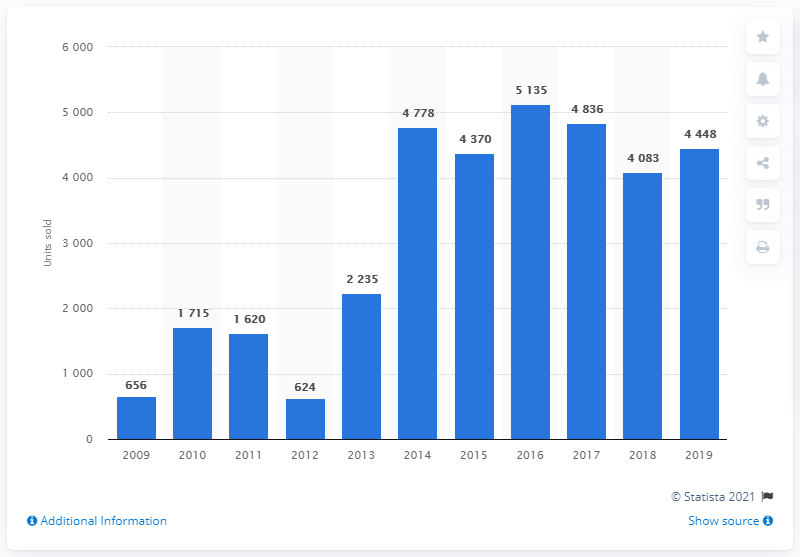List a handful of essential elements in this visual. During the period of 2009 to 2019, a total of 5,135 Dacia cars were sold in Sweden, which was the highest number of sales during that time frame. In 2019, a total of 4448 units of Dacia cars were sold in Sweden. 